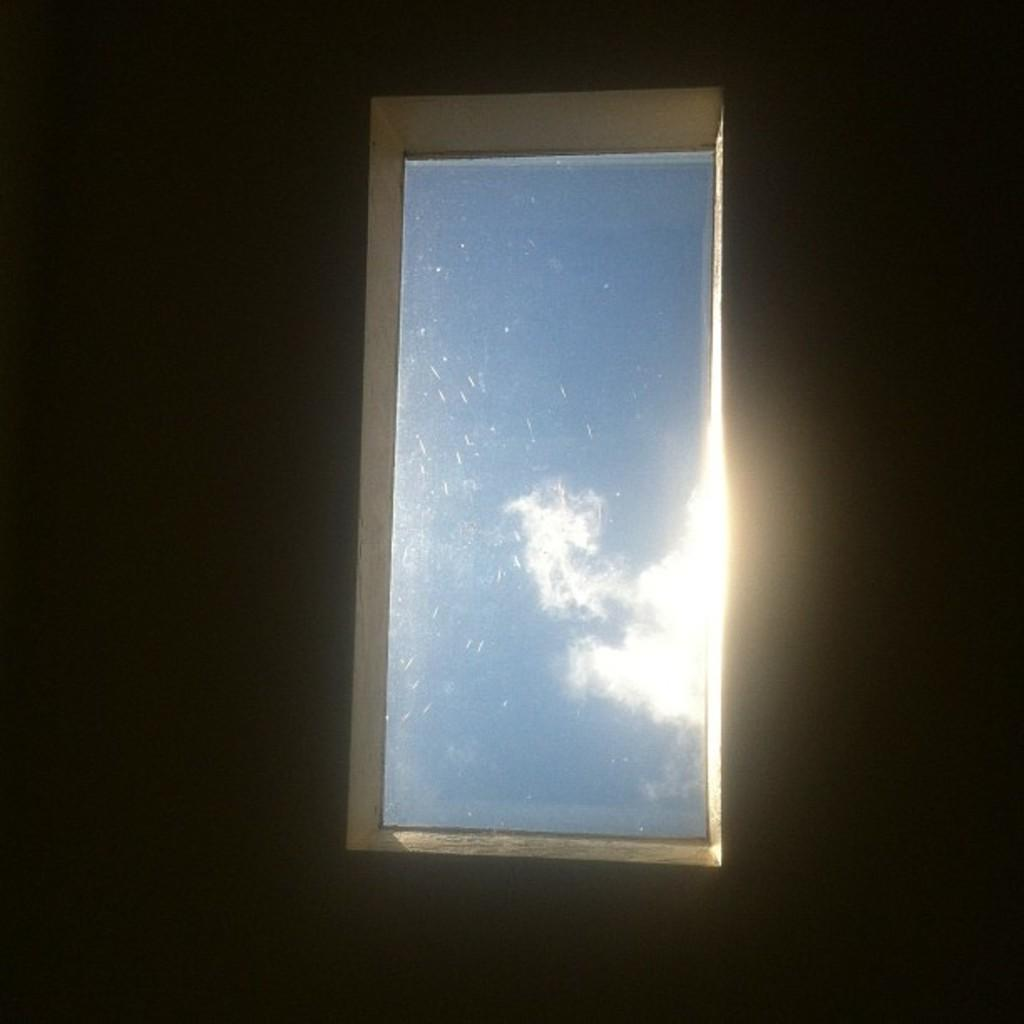Where was the image most likely taken? The image was likely taken indoors. What can be seen in the center of the image? There is a window in the center of the image. What is visible through the window? The sky is visible through the window. What can be observed in the sky? Clouds are visible in the sky. How would you describe the lighting in the image? The background of the image is dark. What type of quilt is being used to blow the clouds away in the image? There is no quilt or blowing of clouds in the image; it simply shows a window with a view of the sky and clouds. 